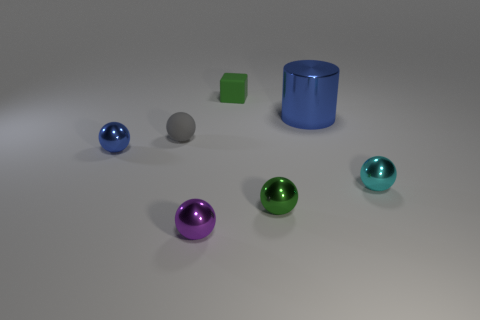Add 2 blue spheres. How many objects exist? 9 Subtract all cylinders. How many objects are left? 6 Add 6 rubber things. How many rubber things are left? 8 Add 4 big blue things. How many big blue things exist? 5 Subtract 1 purple spheres. How many objects are left? 6 Subtract all small blue balls. Subtract all small red rubber cubes. How many objects are left? 6 